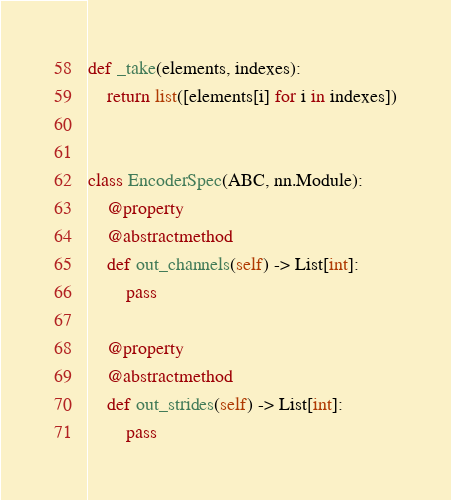<code> <loc_0><loc_0><loc_500><loc_500><_Python_>def _take(elements, indexes):
    return list([elements[i] for i in indexes])


class EncoderSpec(ABC, nn.Module):
    @property
    @abstractmethod
    def out_channels(self) -> List[int]:
        pass

    @property
    @abstractmethod
    def out_strides(self) -> List[int]:
        pass
</code> 